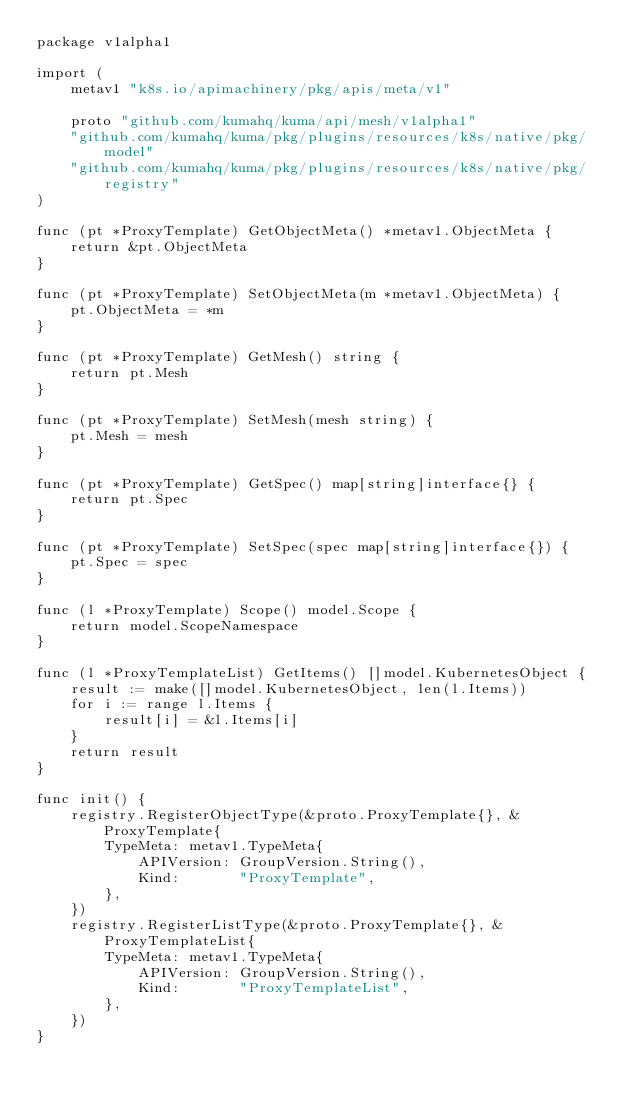<code> <loc_0><loc_0><loc_500><loc_500><_Go_>package v1alpha1

import (
	metav1 "k8s.io/apimachinery/pkg/apis/meta/v1"

	proto "github.com/kumahq/kuma/api/mesh/v1alpha1"
	"github.com/kumahq/kuma/pkg/plugins/resources/k8s/native/pkg/model"
	"github.com/kumahq/kuma/pkg/plugins/resources/k8s/native/pkg/registry"
)

func (pt *ProxyTemplate) GetObjectMeta() *metav1.ObjectMeta {
	return &pt.ObjectMeta
}

func (pt *ProxyTemplate) SetObjectMeta(m *metav1.ObjectMeta) {
	pt.ObjectMeta = *m
}

func (pt *ProxyTemplate) GetMesh() string {
	return pt.Mesh
}

func (pt *ProxyTemplate) SetMesh(mesh string) {
	pt.Mesh = mesh
}

func (pt *ProxyTemplate) GetSpec() map[string]interface{} {
	return pt.Spec
}

func (pt *ProxyTemplate) SetSpec(spec map[string]interface{}) {
	pt.Spec = spec
}

func (l *ProxyTemplate) Scope() model.Scope {
	return model.ScopeNamespace
}

func (l *ProxyTemplateList) GetItems() []model.KubernetesObject {
	result := make([]model.KubernetesObject, len(l.Items))
	for i := range l.Items {
		result[i] = &l.Items[i]
	}
	return result
}

func init() {
	registry.RegisterObjectType(&proto.ProxyTemplate{}, &ProxyTemplate{
		TypeMeta: metav1.TypeMeta{
			APIVersion: GroupVersion.String(),
			Kind:       "ProxyTemplate",
		},
	})
	registry.RegisterListType(&proto.ProxyTemplate{}, &ProxyTemplateList{
		TypeMeta: metav1.TypeMeta{
			APIVersion: GroupVersion.String(),
			Kind:       "ProxyTemplateList",
		},
	})
}
</code> 